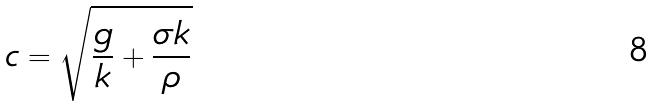<formula> <loc_0><loc_0><loc_500><loc_500>c = \sqrt { \frac { g } { k } + \frac { \sigma k } { \rho } }</formula> 